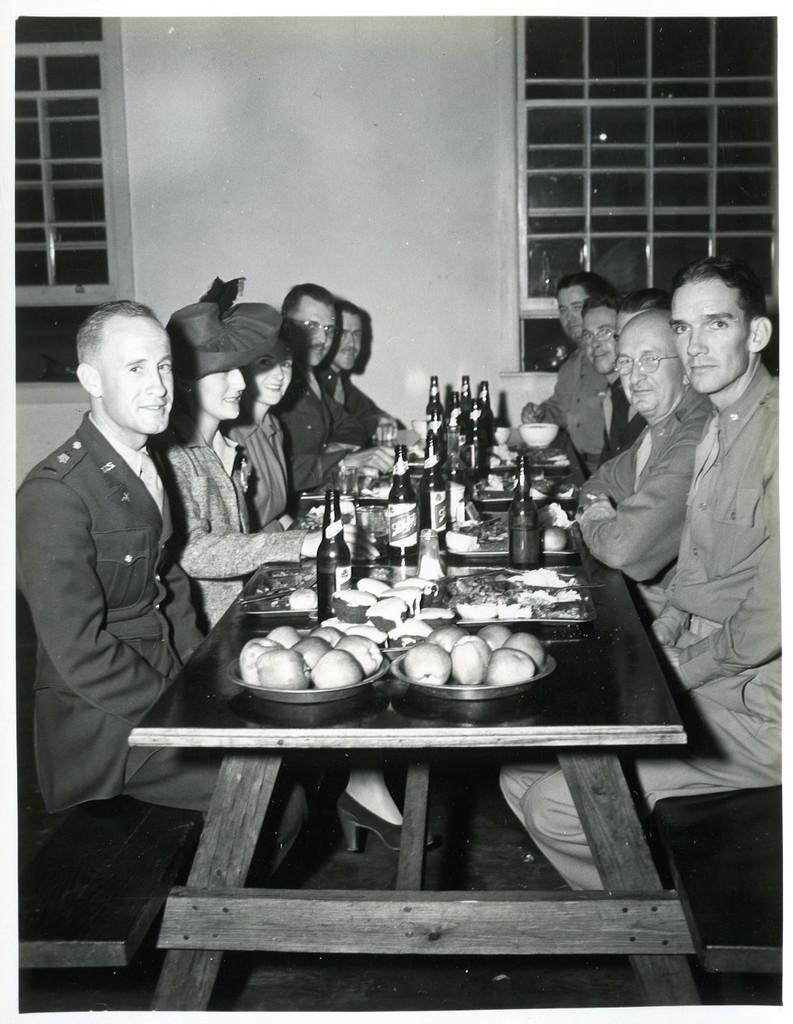How many people are in the image? There is a group of persons in the image. What are the persons in the image doing? The persons are sitting in front of a table. What can be seen on the table in the image? There are eatables and drinks on the table. What is visible in the background of the image? There is a window in the background of the image. What type of hen can be seen in the image? There is no hen present in the image. What is the caption for the image? The image does not have a caption, as it is a still image without any accompanying text. 